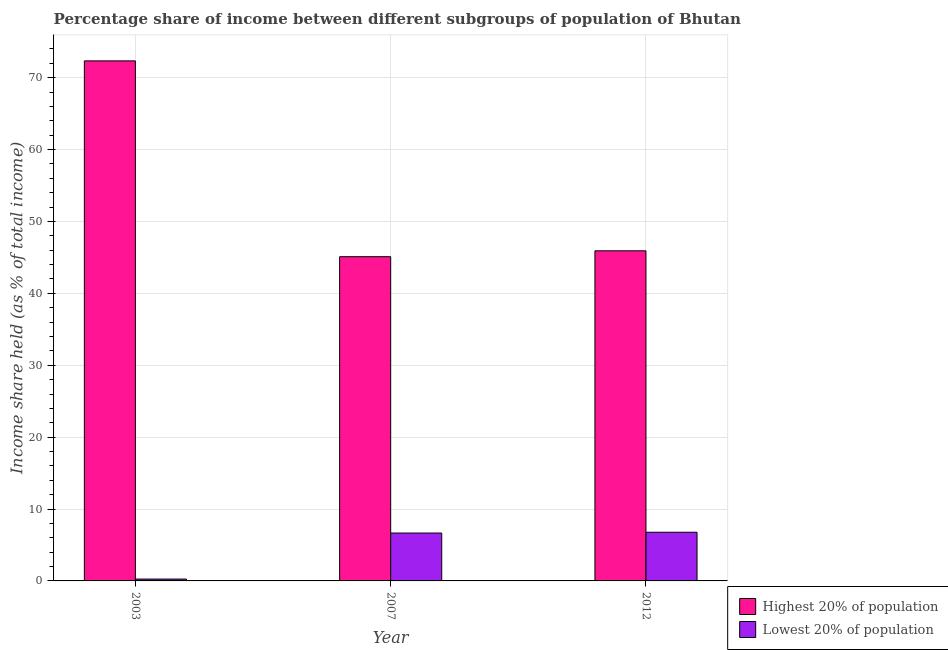Are the number of bars per tick equal to the number of legend labels?
Keep it short and to the point. Yes. How many bars are there on the 2nd tick from the left?
Offer a terse response. 2. What is the label of the 2nd group of bars from the left?
Your answer should be very brief. 2007. What is the income share held by lowest 20% of the population in 2007?
Provide a short and direct response. 6.66. Across all years, what is the maximum income share held by lowest 20% of the population?
Your answer should be very brief. 6.77. Across all years, what is the minimum income share held by highest 20% of the population?
Provide a succinct answer. 45.1. What is the total income share held by lowest 20% of the population in the graph?
Make the answer very short. 13.69. What is the difference between the income share held by lowest 20% of the population in 2007 and that in 2012?
Offer a terse response. -0.11. What is the difference between the income share held by lowest 20% of the population in 2007 and the income share held by highest 20% of the population in 2003?
Offer a very short reply. 6.4. What is the average income share held by lowest 20% of the population per year?
Provide a succinct answer. 4.56. What is the ratio of the income share held by lowest 20% of the population in 2003 to that in 2007?
Your answer should be very brief. 0.04. What is the difference between the highest and the second highest income share held by highest 20% of the population?
Ensure brevity in your answer.  26.42. What is the difference between the highest and the lowest income share held by highest 20% of the population?
Make the answer very short. 27.24. Is the sum of the income share held by lowest 20% of the population in 2007 and 2012 greater than the maximum income share held by highest 20% of the population across all years?
Offer a very short reply. Yes. What does the 1st bar from the left in 2003 represents?
Provide a short and direct response. Highest 20% of population. What does the 2nd bar from the right in 2007 represents?
Offer a very short reply. Highest 20% of population. Are all the bars in the graph horizontal?
Keep it short and to the point. No. Does the graph contain any zero values?
Make the answer very short. No. Does the graph contain grids?
Your answer should be compact. Yes. Where does the legend appear in the graph?
Your response must be concise. Bottom right. How are the legend labels stacked?
Keep it short and to the point. Vertical. What is the title of the graph?
Offer a terse response. Percentage share of income between different subgroups of population of Bhutan. Does "Commercial service exports" appear as one of the legend labels in the graph?
Provide a succinct answer. No. What is the label or title of the X-axis?
Keep it short and to the point. Year. What is the label or title of the Y-axis?
Your response must be concise. Income share held (as % of total income). What is the Income share held (as % of total income) in Highest 20% of population in 2003?
Your response must be concise. 72.34. What is the Income share held (as % of total income) of Lowest 20% of population in 2003?
Offer a very short reply. 0.26. What is the Income share held (as % of total income) in Highest 20% of population in 2007?
Provide a short and direct response. 45.1. What is the Income share held (as % of total income) of Lowest 20% of population in 2007?
Keep it short and to the point. 6.66. What is the Income share held (as % of total income) of Highest 20% of population in 2012?
Keep it short and to the point. 45.92. What is the Income share held (as % of total income) of Lowest 20% of population in 2012?
Offer a terse response. 6.77. Across all years, what is the maximum Income share held (as % of total income) in Highest 20% of population?
Make the answer very short. 72.34. Across all years, what is the maximum Income share held (as % of total income) in Lowest 20% of population?
Your response must be concise. 6.77. Across all years, what is the minimum Income share held (as % of total income) in Highest 20% of population?
Provide a short and direct response. 45.1. Across all years, what is the minimum Income share held (as % of total income) in Lowest 20% of population?
Make the answer very short. 0.26. What is the total Income share held (as % of total income) in Highest 20% of population in the graph?
Provide a succinct answer. 163.36. What is the total Income share held (as % of total income) of Lowest 20% of population in the graph?
Give a very brief answer. 13.69. What is the difference between the Income share held (as % of total income) of Highest 20% of population in 2003 and that in 2007?
Your answer should be very brief. 27.24. What is the difference between the Income share held (as % of total income) of Highest 20% of population in 2003 and that in 2012?
Offer a very short reply. 26.42. What is the difference between the Income share held (as % of total income) of Lowest 20% of population in 2003 and that in 2012?
Provide a succinct answer. -6.51. What is the difference between the Income share held (as % of total income) in Highest 20% of population in 2007 and that in 2012?
Offer a very short reply. -0.82. What is the difference between the Income share held (as % of total income) of Lowest 20% of population in 2007 and that in 2012?
Offer a very short reply. -0.11. What is the difference between the Income share held (as % of total income) of Highest 20% of population in 2003 and the Income share held (as % of total income) of Lowest 20% of population in 2007?
Give a very brief answer. 65.68. What is the difference between the Income share held (as % of total income) in Highest 20% of population in 2003 and the Income share held (as % of total income) in Lowest 20% of population in 2012?
Make the answer very short. 65.57. What is the difference between the Income share held (as % of total income) of Highest 20% of population in 2007 and the Income share held (as % of total income) of Lowest 20% of population in 2012?
Provide a succinct answer. 38.33. What is the average Income share held (as % of total income) in Highest 20% of population per year?
Ensure brevity in your answer.  54.45. What is the average Income share held (as % of total income) of Lowest 20% of population per year?
Make the answer very short. 4.56. In the year 2003, what is the difference between the Income share held (as % of total income) in Highest 20% of population and Income share held (as % of total income) in Lowest 20% of population?
Give a very brief answer. 72.08. In the year 2007, what is the difference between the Income share held (as % of total income) of Highest 20% of population and Income share held (as % of total income) of Lowest 20% of population?
Provide a succinct answer. 38.44. In the year 2012, what is the difference between the Income share held (as % of total income) of Highest 20% of population and Income share held (as % of total income) of Lowest 20% of population?
Keep it short and to the point. 39.15. What is the ratio of the Income share held (as % of total income) in Highest 20% of population in 2003 to that in 2007?
Give a very brief answer. 1.6. What is the ratio of the Income share held (as % of total income) in Lowest 20% of population in 2003 to that in 2007?
Your answer should be compact. 0.04. What is the ratio of the Income share held (as % of total income) in Highest 20% of population in 2003 to that in 2012?
Your answer should be compact. 1.58. What is the ratio of the Income share held (as % of total income) of Lowest 20% of population in 2003 to that in 2012?
Provide a succinct answer. 0.04. What is the ratio of the Income share held (as % of total income) of Highest 20% of population in 2007 to that in 2012?
Offer a very short reply. 0.98. What is the ratio of the Income share held (as % of total income) in Lowest 20% of population in 2007 to that in 2012?
Your response must be concise. 0.98. What is the difference between the highest and the second highest Income share held (as % of total income) of Highest 20% of population?
Ensure brevity in your answer.  26.42. What is the difference between the highest and the second highest Income share held (as % of total income) of Lowest 20% of population?
Offer a terse response. 0.11. What is the difference between the highest and the lowest Income share held (as % of total income) in Highest 20% of population?
Provide a short and direct response. 27.24. What is the difference between the highest and the lowest Income share held (as % of total income) in Lowest 20% of population?
Provide a short and direct response. 6.51. 